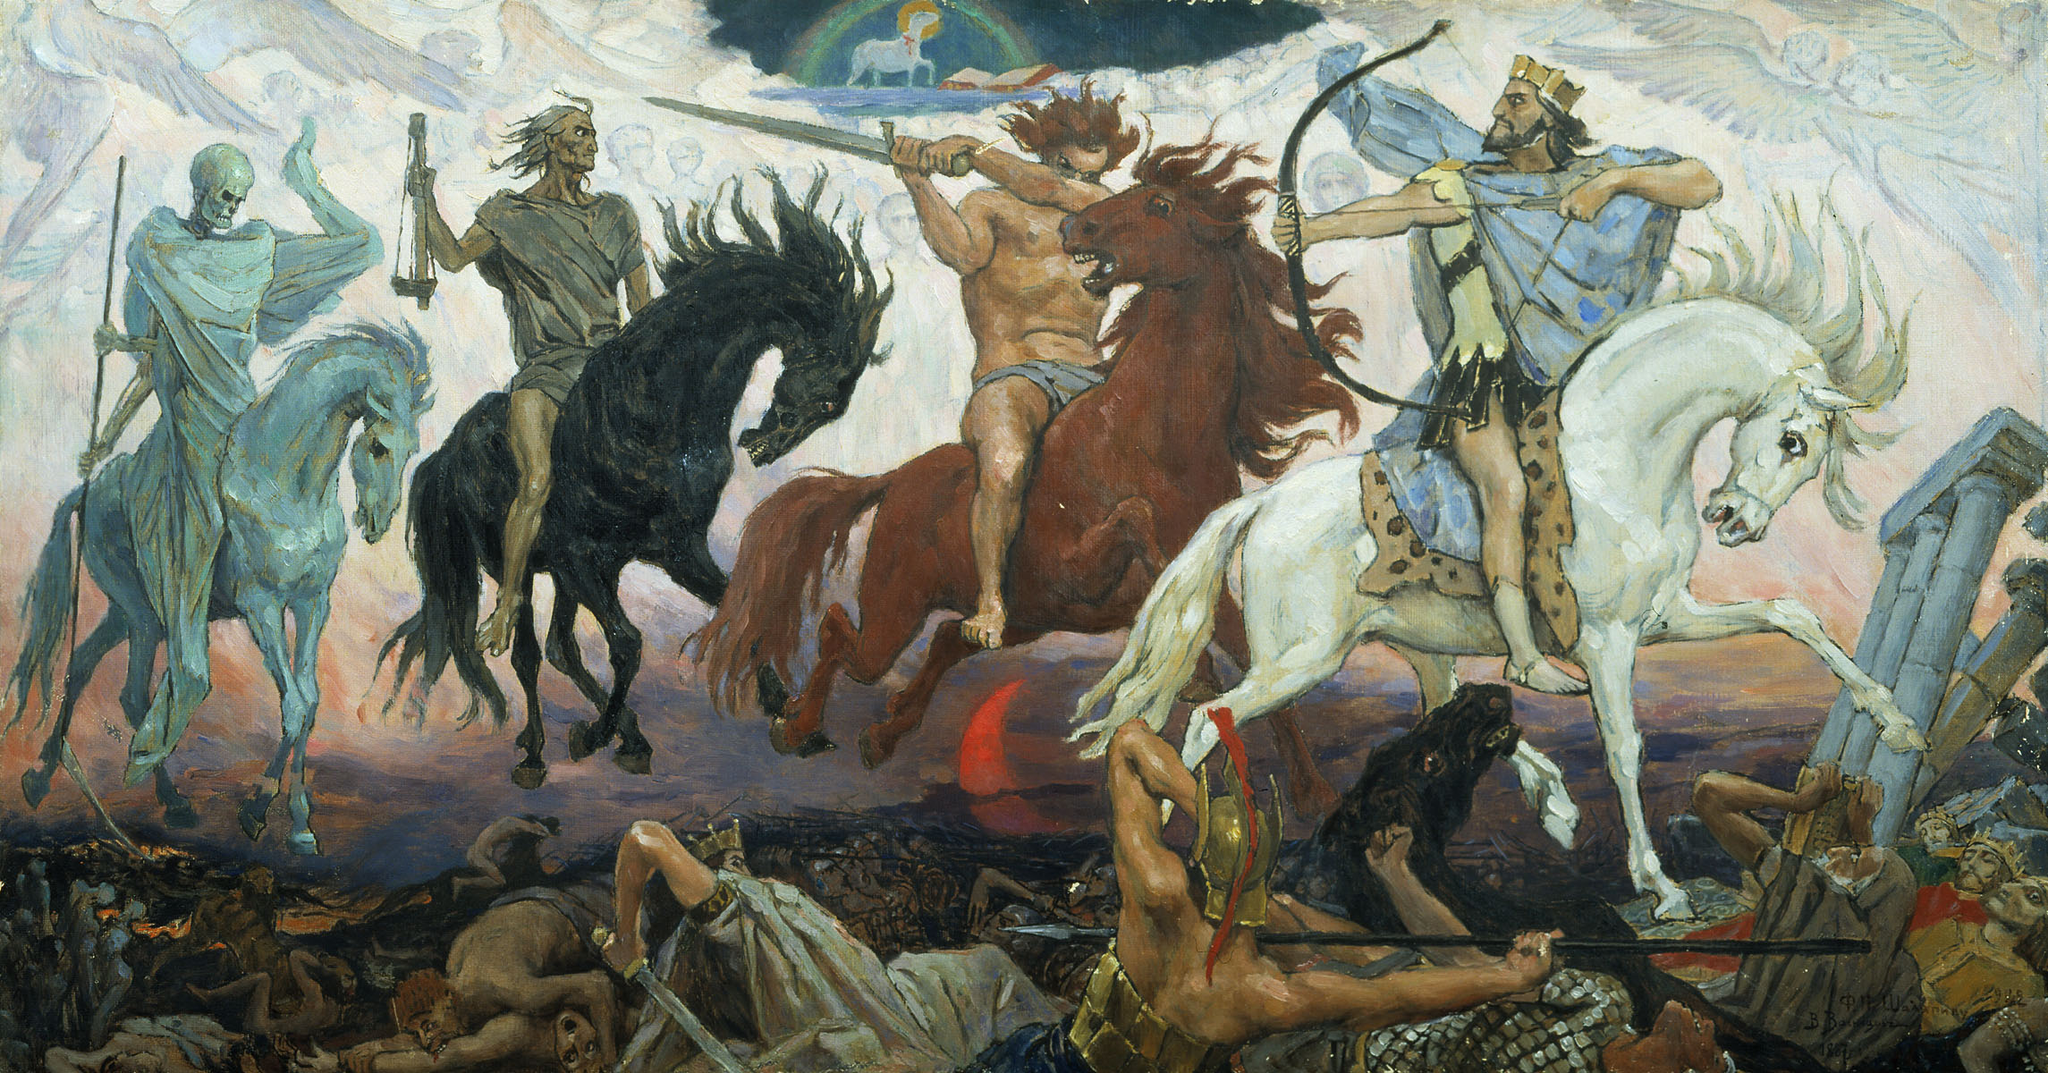Who might the central four figures represent in this mythical battle, and what could their presence symbolize? The central figures might represent apocalyptic riders or gods from various mythologies, embodying themes of war, death, and kinghood. Each figure's attire and posture could symbolize different aspects of power and mortality in the mythic narrative, reflecting the folklore around divine or heroic battle interventions. Can you describe the symbolism of the colors used in the painting? Certainly, the use of vibrant reds and deep blues enhances the painting's dramatic effect, symbolizing violence, valor, and noble sacrifice. The stark contrasts between the fiery reds and icy blues could denote the clash between life and death, or heat and cold, suggesting a battle between opposing elemental forces. 